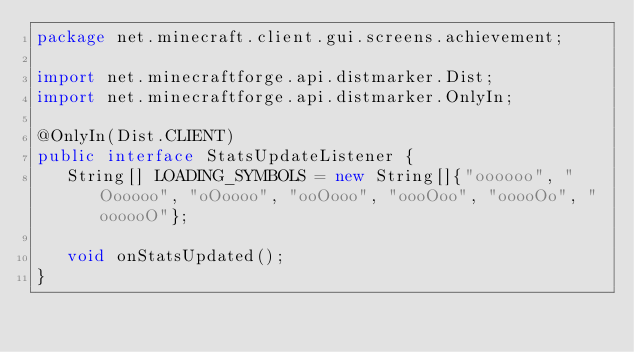Convert code to text. <code><loc_0><loc_0><loc_500><loc_500><_Java_>package net.minecraft.client.gui.screens.achievement;

import net.minecraftforge.api.distmarker.Dist;
import net.minecraftforge.api.distmarker.OnlyIn;

@OnlyIn(Dist.CLIENT)
public interface StatsUpdateListener {
   String[] LOADING_SYMBOLS = new String[]{"oooooo", "Oooooo", "oOoooo", "ooOooo", "oooOoo", "ooooOo", "oooooO"};

   void onStatsUpdated();
}</code> 